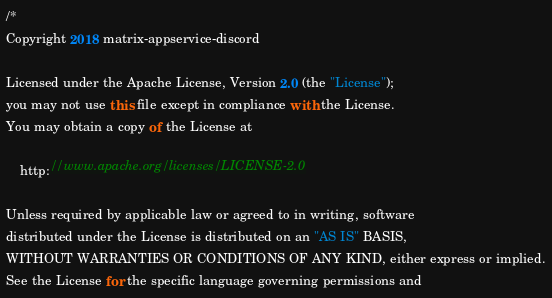<code> <loc_0><loc_0><loc_500><loc_500><_TypeScript_>/*
Copyright 2018 matrix-appservice-discord

Licensed under the Apache License, Version 2.0 (the "License");
you may not use this file except in compliance with the License.
You may obtain a copy of the License at

    http://www.apache.org/licenses/LICENSE-2.0

Unless required by applicable law or agreed to in writing, software
distributed under the License is distributed on an "AS IS" BASIS,
WITHOUT WARRANTIES OR CONDITIONS OF ANY KIND, either express or implied.
See the License for the specific language governing permissions and</code> 